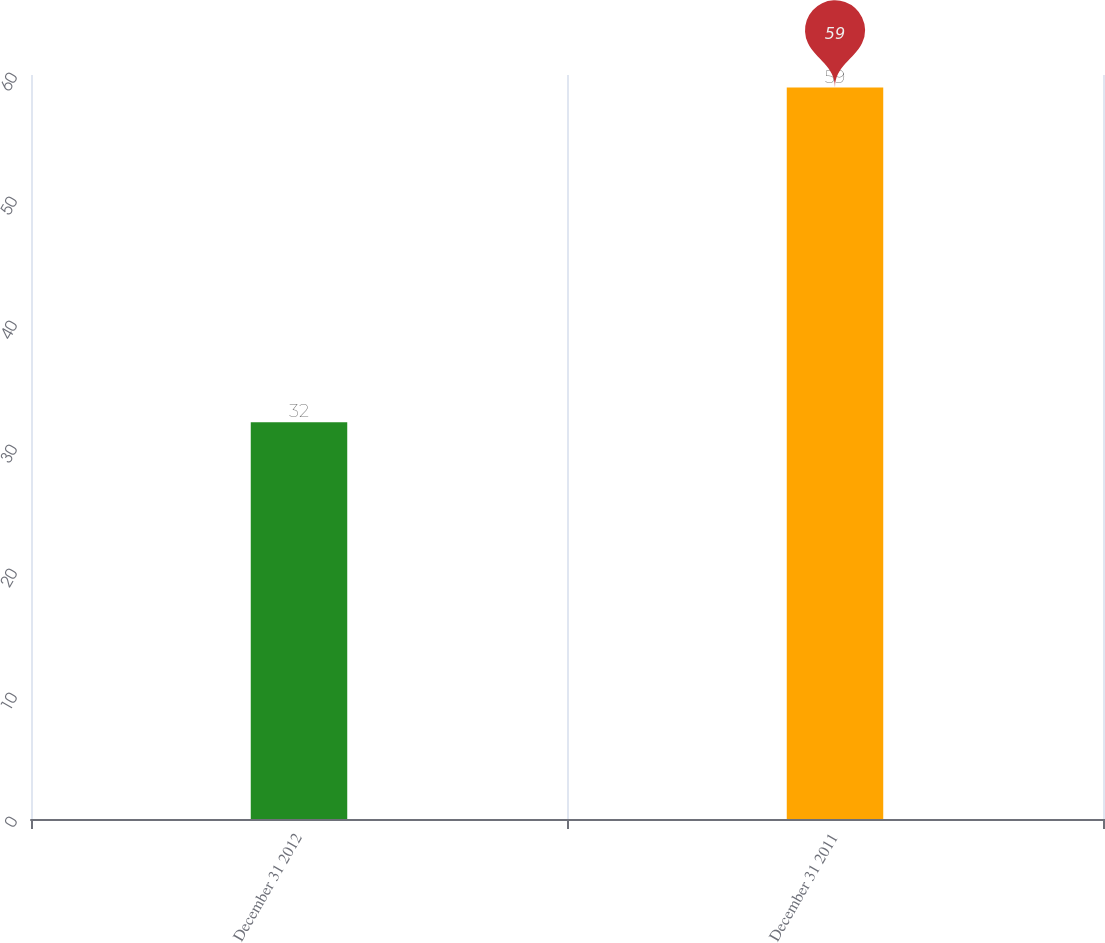Convert chart. <chart><loc_0><loc_0><loc_500><loc_500><bar_chart><fcel>December 31 2012<fcel>December 31 2011<nl><fcel>32<fcel>59<nl></chart> 